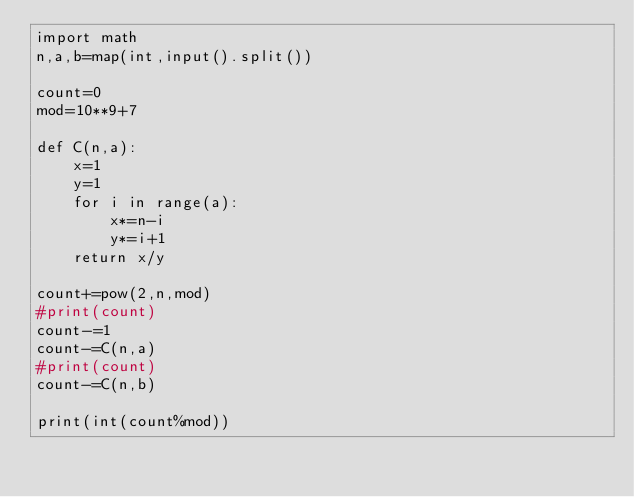Convert code to text. <code><loc_0><loc_0><loc_500><loc_500><_Python_>import math
n,a,b=map(int,input().split())

count=0
mod=10**9+7

def C(n,a):
    x=1
    y=1
    for i in range(a):
        x*=n-i
        y*=i+1
    return x/y

count+=pow(2,n,mod)
#print(count)
count-=1
count-=C(n,a)
#print(count)
count-=C(n,b)

print(int(count%mod))</code> 